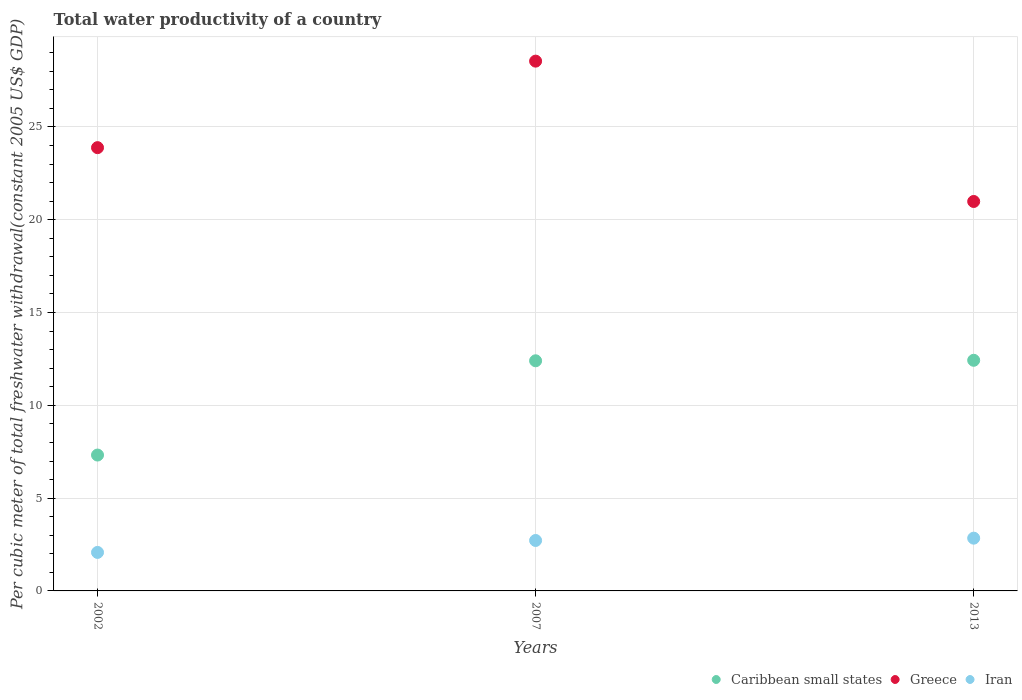How many different coloured dotlines are there?
Offer a very short reply. 3. What is the total water productivity in Iran in 2013?
Provide a short and direct response. 2.84. Across all years, what is the maximum total water productivity in Greece?
Provide a short and direct response. 28.55. Across all years, what is the minimum total water productivity in Caribbean small states?
Provide a short and direct response. 7.32. In which year was the total water productivity in Greece maximum?
Ensure brevity in your answer.  2007. In which year was the total water productivity in Iran minimum?
Ensure brevity in your answer.  2002. What is the total total water productivity in Caribbean small states in the graph?
Provide a succinct answer. 32.15. What is the difference between the total water productivity in Iran in 2002 and that in 2007?
Your answer should be very brief. -0.64. What is the difference between the total water productivity in Iran in 2013 and the total water productivity in Greece in 2007?
Your answer should be very brief. -25.7. What is the average total water productivity in Greece per year?
Ensure brevity in your answer.  24.47. In the year 2007, what is the difference between the total water productivity in Greece and total water productivity in Caribbean small states?
Offer a terse response. 16.15. What is the ratio of the total water productivity in Iran in 2007 to that in 2013?
Provide a short and direct response. 0.96. What is the difference between the highest and the second highest total water productivity in Greece?
Keep it short and to the point. 4.66. What is the difference between the highest and the lowest total water productivity in Iran?
Offer a terse response. 0.77. How many years are there in the graph?
Offer a terse response. 3. What is the difference between two consecutive major ticks on the Y-axis?
Provide a short and direct response. 5. Are the values on the major ticks of Y-axis written in scientific E-notation?
Your answer should be very brief. No. Does the graph contain any zero values?
Give a very brief answer. No. Does the graph contain grids?
Ensure brevity in your answer.  Yes. Where does the legend appear in the graph?
Your answer should be very brief. Bottom right. How many legend labels are there?
Provide a succinct answer. 3. How are the legend labels stacked?
Your response must be concise. Horizontal. What is the title of the graph?
Give a very brief answer. Total water productivity of a country. What is the label or title of the Y-axis?
Offer a terse response. Per cubic meter of total freshwater withdrawal(constant 2005 US$ GDP). What is the Per cubic meter of total freshwater withdrawal(constant 2005 US$ GDP) of Caribbean small states in 2002?
Make the answer very short. 7.32. What is the Per cubic meter of total freshwater withdrawal(constant 2005 US$ GDP) in Greece in 2002?
Make the answer very short. 23.88. What is the Per cubic meter of total freshwater withdrawal(constant 2005 US$ GDP) of Iran in 2002?
Your answer should be compact. 2.07. What is the Per cubic meter of total freshwater withdrawal(constant 2005 US$ GDP) in Caribbean small states in 2007?
Make the answer very short. 12.4. What is the Per cubic meter of total freshwater withdrawal(constant 2005 US$ GDP) in Greece in 2007?
Your answer should be very brief. 28.55. What is the Per cubic meter of total freshwater withdrawal(constant 2005 US$ GDP) of Iran in 2007?
Offer a very short reply. 2.72. What is the Per cubic meter of total freshwater withdrawal(constant 2005 US$ GDP) in Caribbean small states in 2013?
Your answer should be compact. 12.43. What is the Per cubic meter of total freshwater withdrawal(constant 2005 US$ GDP) of Greece in 2013?
Provide a succinct answer. 20.98. What is the Per cubic meter of total freshwater withdrawal(constant 2005 US$ GDP) of Iran in 2013?
Offer a very short reply. 2.84. Across all years, what is the maximum Per cubic meter of total freshwater withdrawal(constant 2005 US$ GDP) in Caribbean small states?
Provide a succinct answer. 12.43. Across all years, what is the maximum Per cubic meter of total freshwater withdrawal(constant 2005 US$ GDP) of Greece?
Ensure brevity in your answer.  28.55. Across all years, what is the maximum Per cubic meter of total freshwater withdrawal(constant 2005 US$ GDP) in Iran?
Keep it short and to the point. 2.84. Across all years, what is the minimum Per cubic meter of total freshwater withdrawal(constant 2005 US$ GDP) of Caribbean small states?
Keep it short and to the point. 7.32. Across all years, what is the minimum Per cubic meter of total freshwater withdrawal(constant 2005 US$ GDP) in Greece?
Offer a terse response. 20.98. Across all years, what is the minimum Per cubic meter of total freshwater withdrawal(constant 2005 US$ GDP) of Iran?
Your answer should be compact. 2.07. What is the total Per cubic meter of total freshwater withdrawal(constant 2005 US$ GDP) in Caribbean small states in the graph?
Offer a very short reply. 32.15. What is the total Per cubic meter of total freshwater withdrawal(constant 2005 US$ GDP) in Greece in the graph?
Give a very brief answer. 73.41. What is the total Per cubic meter of total freshwater withdrawal(constant 2005 US$ GDP) in Iran in the graph?
Your answer should be compact. 7.64. What is the difference between the Per cubic meter of total freshwater withdrawal(constant 2005 US$ GDP) in Caribbean small states in 2002 and that in 2007?
Offer a terse response. -5.08. What is the difference between the Per cubic meter of total freshwater withdrawal(constant 2005 US$ GDP) of Greece in 2002 and that in 2007?
Your answer should be very brief. -4.66. What is the difference between the Per cubic meter of total freshwater withdrawal(constant 2005 US$ GDP) in Iran in 2002 and that in 2007?
Ensure brevity in your answer.  -0.64. What is the difference between the Per cubic meter of total freshwater withdrawal(constant 2005 US$ GDP) in Caribbean small states in 2002 and that in 2013?
Provide a succinct answer. -5.11. What is the difference between the Per cubic meter of total freshwater withdrawal(constant 2005 US$ GDP) in Greece in 2002 and that in 2013?
Your answer should be very brief. 2.9. What is the difference between the Per cubic meter of total freshwater withdrawal(constant 2005 US$ GDP) of Iran in 2002 and that in 2013?
Provide a succinct answer. -0.77. What is the difference between the Per cubic meter of total freshwater withdrawal(constant 2005 US$ GDP) in Caribbean small states in 2007 and that in 2013?
Give a very brief answer. -0.03. What is the difference between the Per cubic meter of total freshwater withdrawal(constant 2005 US$ GDP) of Greece in 2007 and that in 2013?
Your answer should be very brief. 7.56. What is the difference between the Per cubic meter of total freshwater withdrawal(constant 2005 US$ GDP) in Iran in 2007 and that in 2013?
Provide a succinct answer. -0.12. What is the difference between the Per cubic meter of total freshwater withdrawal(constant 2005 US$ GDP) in Caribbean small states in 2002 and the Per cubic meter of total freshwater withdrawal(constant 2005 US$ GDP) in Greece in 2007?
Make the answer very short. -21.22. What is the difference between the Per cubic meter of total freshwater withdrawal(constant 2005 US$ GDP) in Caribbean small states in 2002 and the Per cubic meter of total freshwater withdrawal(constant 2005 US$ GDP) in Iran in 2007?
Your answer should be very brief. 4.6. What is the difference between the Per cubic meter of total freshwater withdrawal(constant 2005 US$ GDP) in Greece in 2002 and the Per cubic meter of total freshwater withdrawal(constant 2005 US$ GDP) in Iran in 2007?
Offer a very short reply. 21.17. What is the difference between the Per cubic meter of total freshwater withdrawal(constant 2005 US$ GDP) in Caribbean small states in 2002 and the Per cubic meter of total freshwater withdrawal(constant 2005 US$ GDP) in Greece in 2013?
Give a very brief answer. -13.66. What is the difference between the Per cubic meter of total freshwater withdrawal(constant 2005 US$ GDP) in Caribbean small states in 2002 and the Per cubic meter of total freshwater withdrawal(constant 2005 US$ GDP) in Iran in 2013?
Provide a succinct answer. 4.48. What is the difference between the Per cubic meter of total freshwater withdrawal(constant 2005 US$ GDP) of Greece in 2002 and the Per cubic meter of total freshwater withdrawal(constant 2005 US$ GDP) of Iran in 2013?
Ensure brevity in your answer.  21.04. What is the difference between the Per cubic meter of total freshwater withdrawal(constant 2005 US$ GDP) in Caribbean small states in 2007 and the Per cubic meter of total freshwater withdrawal(constant 2005 US$ GDP) in Greece in 2013?
Provide a short and direct response. -8.58. What is the difference between the Per cubic meter of total freshwater withdrawal(constant 2005 US$ GDP) of Caribbean small states in 2007 and the Per cubic meter of total freshwater withdrawal(constant 2005 US$ GDP) of Iran in 2013?
Your response must be concise. 9.56. What is the difference between the Per cubic meter of total freshwater withdrawal(constant 2005 US$ GDP) of Greece in 2007 and the Per cubic meter of total freshwater withdrawal(constant 2005 US$ GDP) of Iran in 2013?
Ensure brevity in your answer.  25.7. What is the average Per cubic meter of total freshwater withdrawal(constant 2005 US$ GDP) of Caribbean small states per year?
Provide a succinct answer. 10.72. What is the average Per cubic meter of total freshwater withdrawal(constant 2005 US$ GDP) of Greece per year?
Provide a short and direct response. 24.47. What is the average Per cubic meter of total freshwater withdrawal(constant 2005 US$ GDP) in Iran per year?
Keep it short and to the point. 2.55. In the year 2002, what is the difference between the Per cubic meter of total freshwater withdrawal(constant 2005 US$ GDP) in Caribbean small states and Per cubic meter of total freshwater withdrawal(constant 2005 US$ GDP) in Greece?
Offer a terse response. -16.56. In the year 2002, what is the difference between the Per cubic meter of total freshwater withdrawal(constant 2005 US$ GDP) of Caribbean small states and Per cubic meter of total freshwater withdrawal(constant 2005 US$ GDP) of Iran?
Keep it short and to the point. 5.25. In the year 2002, what is the difference between the Per cubic meter of total freshwater withdrawal(constant 2005 US$ GDP) in Greece and Per cubic meter of total freshwater withdrawal(constant 2005 US$ GDP) in Iran?
Your answer should be compact. 21.81. In the year 2007, what is the difference between the Per cubic meter of total freshwater withdrawal(constant 2005 US$ GDP) in Caribbean small states and Per cubic meter of total freshwater withdrawal(constant 2005 US$ GDP) in Greece?
Your answer should be compact. -16.15. In the year 2007, what is the difference between the Per cubic meter of total freshwater withdrawal(constant 2005 US$ GDP) in Caribbean small states and Per cubic meter of total freshwater withdrawal(constant 2005 US$ GDP) in Iran?
Provide a short and direct response. 9.68. In the year 2007, what is the difference between the Per cubic meter of total freshwater withdrawal(constant 2005 US$ GDP) of Greece and Per cubic meter of total freshwater withdrawal(constant 2005 US$ GDP) of Iran?
Your answer should be very brief. 25.83. In the year 2013, what is the difference between the Per cubic meter of total freshwater withdrawal(constant 2005 US$ GDP) of Caribbean small states and Per cubic meter of total freshwater withdrawal(constant 2005 US$ GDP) of Greece?
Keep it short and to the point. -8.56. In the year 2013, what is the difference between the Per cubic meter of total freshwater withdrawal(constant 2005 US$ GDP) of Caribbean small states and Per cubic meter of total freshwater withdrawal(constant 2005 US$ GDP) of Iran?
Offer a terse response. 9.58. In the year 2013, what is the difference between the Per cubic meter of total freshwater withdrawal(constant 2005 US$ GDP) in Greece and Per cubic meter of total freshwater withdrawal(constant 2005 US$ GDP) in Iran?
Offer a very short reply. 18.14. What is the ratio of the Per cubic meter of total freshwater withdrawal(constant 2005 US$ GDP) of Caribbean small states in 2002 to that in 2007?
Offer a terse response. 0.59. What is the ratio of the Per cubic meter of total freshwater withdrawal(constant 2005 US$ GDP) of Greece in 2002 to that in 2007?
Offer a terse response. 0.84. What is the ratio of the Per cubic meter of total freshwater withdrawal(constant 2005 US$ GDP) in Iran in 2002 to that in 2007?
Make the answer very short. 0.76. What is the ratio of the Per cubic meter of total freshwater withdrawal(constant 2005 US$ GDP) in Caribbean small states in 2002 to that in 2013?
Give a very brief answer. 0.59. What is the ratio of the Per cubic meter of total freshwater withdrawal(constant 2005 US$ GDP) of Greece in 2002 to that in 2013?
Ensure brevity in your answer.  1.14. What is the ratio of the Per cubic meter of total freshwater withdrawal(constant 2005 US$ GDP) of Iran in 2002 to that in 2013?
Offer a terse response. 0.73. What is the ratio of the Per cubic meter of total freshwater withdrawal(constant 2005 US$ GDP) in Greece in 2007 to that in 2013?
Your response must be concise. 1.36. What is the ratio of the Per cubic meter of total freshwater withdrawal(constant 2005 US$ GDP) in Iran in 2007 to that in 2013?
Provide a succinct answer. 0.96. What is the difference between the highest and the second highest Per cubic meter of total freshwater withdrawal(constant 2005 US$ GDP) of Caribbean small states?
Your response must be concise. 0.03. What is the difference between the highest and the second highest Per cubic meter of total freshwater withdrawal(constant 2005 US$ GDP) in Greece?
Offer a terse response. 4.66. What is the difference between the highest and the second highest Per cubic meter of total freshwater withdrawal(constant 2005 US$ GDP) of Iran?
Make the answer very short. 0.12. What is the difference between the highest and the lowest Per cubic meter of total freshwater withdrawal(constant 2005 US$ GDP) in Caribbean small states?
Provide a succinct answer. 5.11. What is the difference between the highest and the lowest Per cubic meter of total freshwater withdrawal(constant 2005 US$ GDP) of Greece?
Provide a succinct answer. 7.56. What is the difference between the highest and the lowest Per cubic meter of total freshwater withdrawal(constant 2005 US$ GDP) in Iran?
Provide a succinct answer. 0.77. 